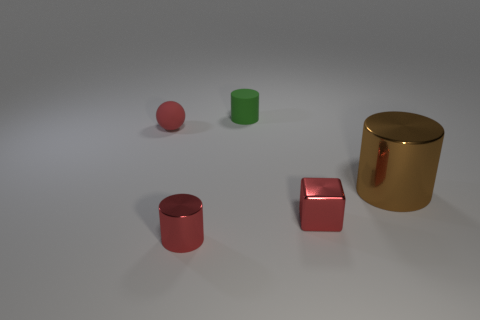Subtract all red metal cylinders. How many cylinders are left? 2 Add 3 green things. How many objects exist? 8 Subtract 3 cylinders. How many cylinders are left? 0 Subtract all brown cylinders. How many cylinders are left? 2 Subtract all blocks. How many objects are left? 4 Subtract all yellow cylinders. How many brown blocks are left? 0 Subtract 0 green blocks. How many objects are left? 5 Subtract all green cylinders. Subtract all red spheres. How many cylinders are left? 2 Subtract all cyan shiny cubes. Subtract all brown metal cylinders. How many objects are left? 4 Add 1 rubber balls. How many rubber balls are left? 2 